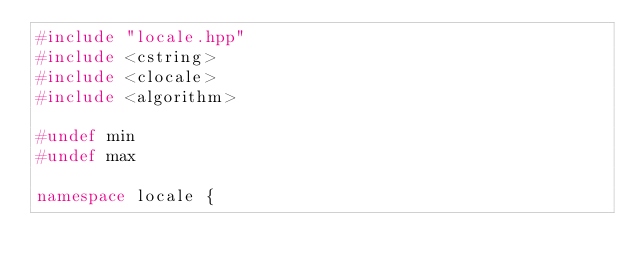<code> <loc_0><loc_0><loc_500><loc_500><_C++_>#include "locale.hpp"
#include <cstring>
#include <clocale>
#include <algorithm>

#undef min
#undef max

namespace locale {
</code> 